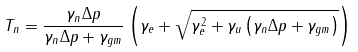<formula> <loc_0><loc_0><loc_500><loc_500>T _ { n } = \frac { \gamma _ { n } \Delta p } { \gamma _ { n } \Delta p + \gamma _ { g m } } \left ( \gamma _ { e } + \sqrt { \gamma _ { e } ^ { 2 } + \gamma _ { u } \left ( \gamma _ { n } \Delta p + \gamma _ { g m } \right ) } \right )</formula> 